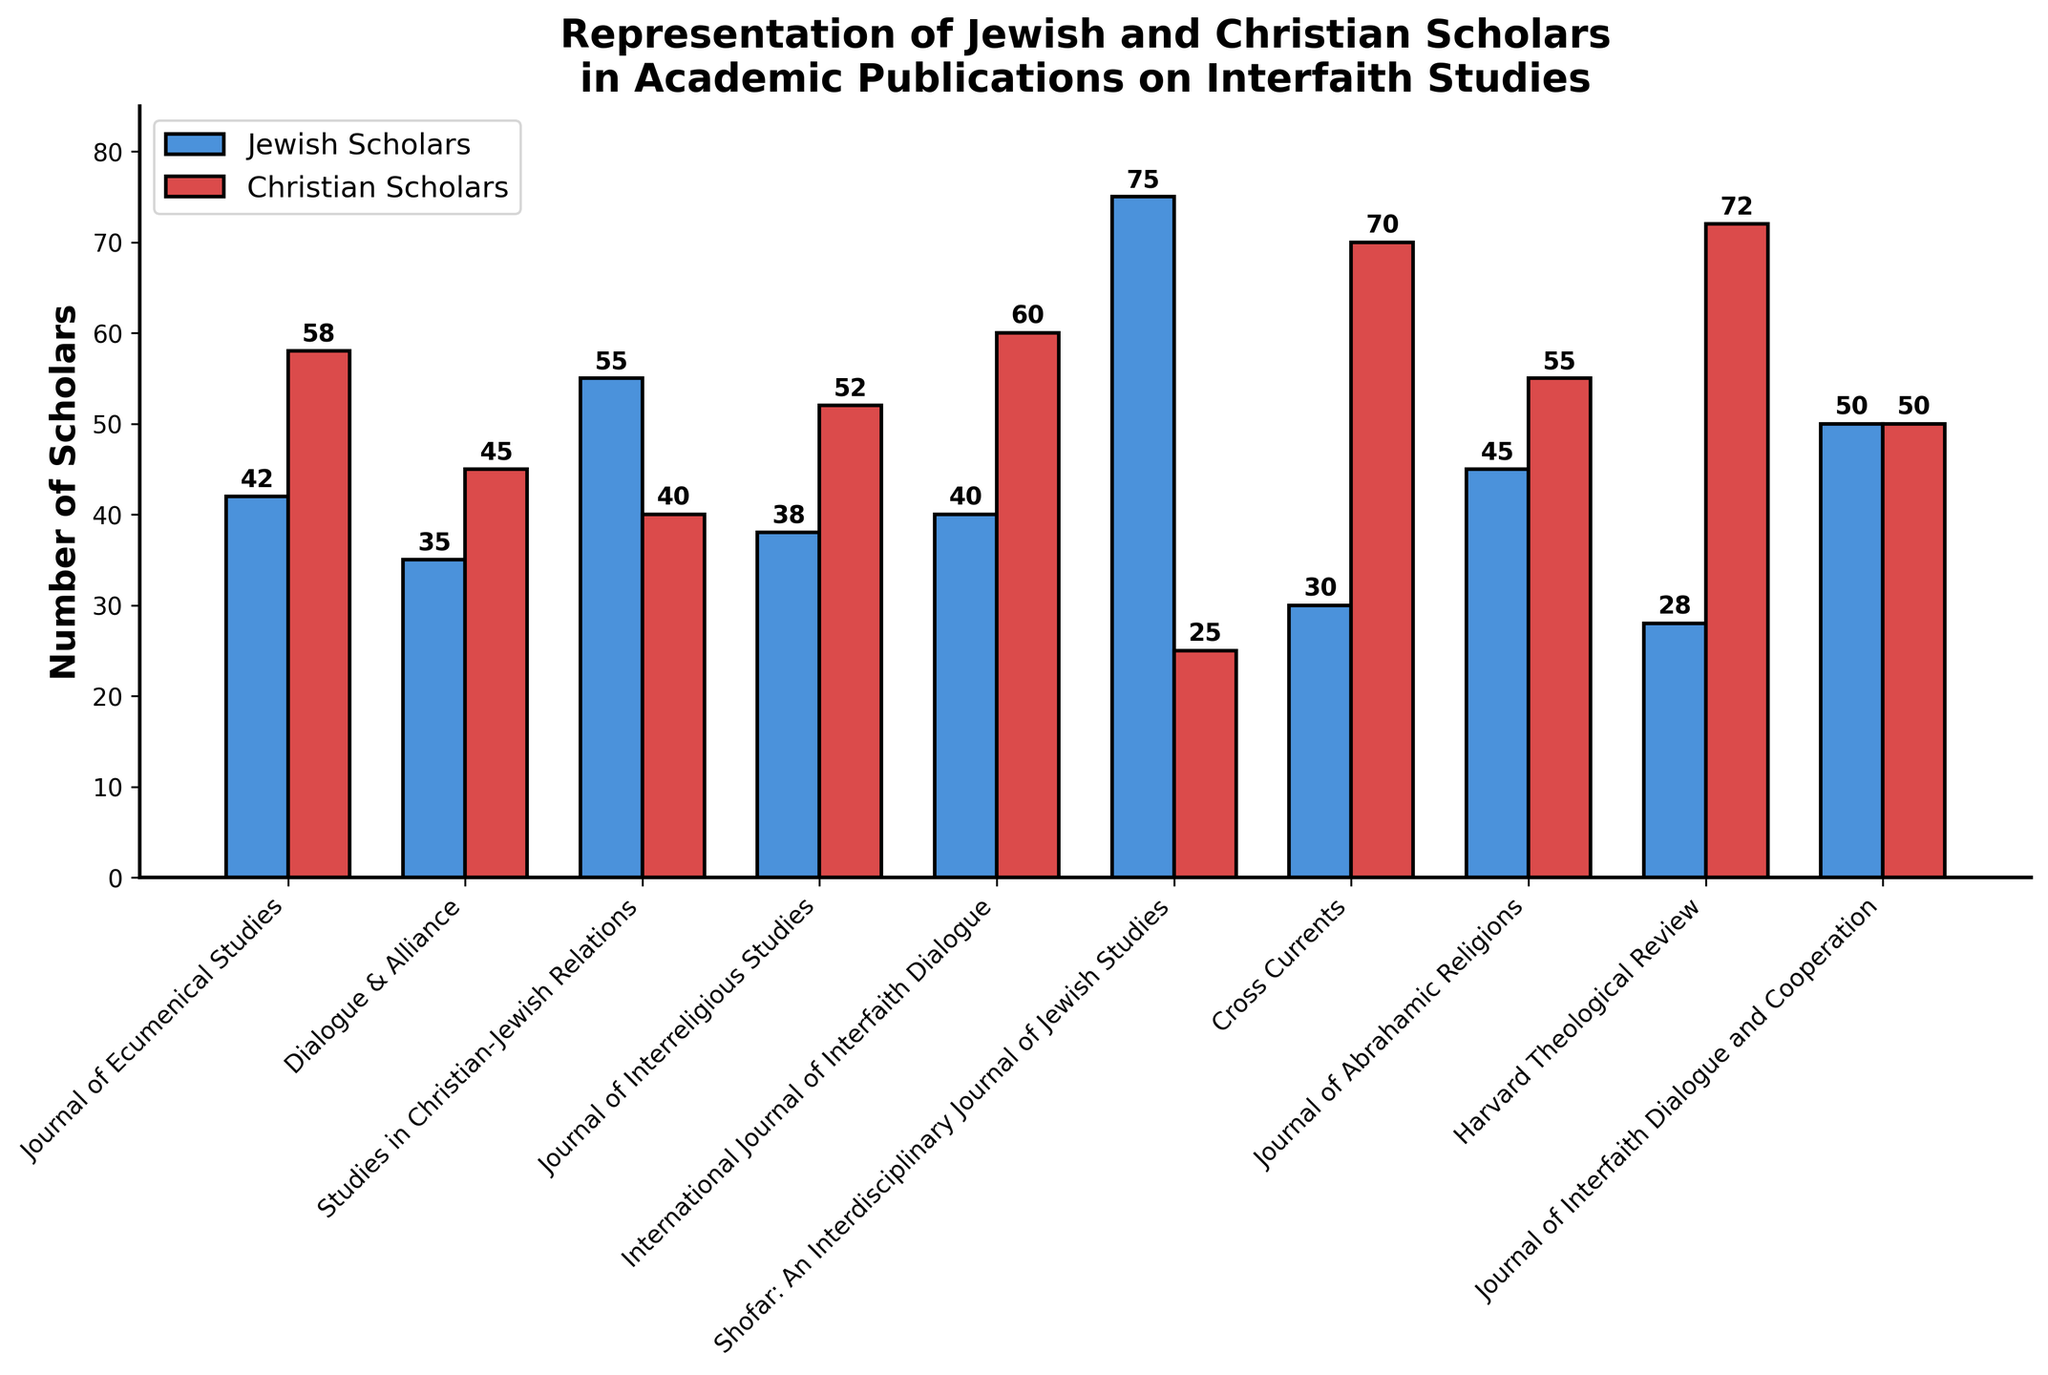What is the total number of scholars for the Journal of Ecumenical Studies? Add the number of Jewish and Christian scholars for the Journal of Ecumenical Studies (42 + 58).
Answer: 100 Which journal has the highest number of Jewish scholars? Compare the bar heights for Jewish Scholars across all journals. Shofar: An Interdisciplinary Journal of Jewish Studies has the highest bar with 75 Jewish scholars.
Answer: Shofar: An Interdisciplinary Journal of Jewish Studies What is the difference between the number of Jewish and Christian scholars in Shofar: An Interdisciplinary Journal of Jewish Studies? Subtract the number of Christian scholars from Jewish scholars for this journal (75 - 25).
Answer: 50 Which journal has an equal representation of Jewish and Christian scholars? Identify the journal where the bar heights for Jewish and Christian Scholars are equal. The Journal of Interfaith Dialogue and Cooperation has equal bars with 50 scholars each.
Answer: Journal of Interfaith Dialogue and Cooperation On average, how many Jewish scholars are published in Journal of Interreligious Studies and International Journal of Interfaith Dialogue? Add the number of Jewish scholars in both journals and divide by 2 ((38 + 40) / 2).
Answer: 39 Which journal has the greatest disparity between the number of Jewish and Christian scholars? Determine the differences between Jewish and Christian scholars for each journal. Harvard Theological Review has the greatest disparity (72 - 28 = 44).
Answer: Harvard Theological Review How many journals have more Christian scholars than Jewish scholars? Compare the heights of bars for Jewish and Christian scholars in each journal and count those where the Christian bar is higher. There are 5 such journals.
Answer: 5 Which journal has the least number of Christian scholars? Compare the bar heights for Christian Scholars across all journals. Shofar: An Interdisciplinary Journal of Jewish Studies has the smallest bar with 25 Christian scholars.
Answer: Shofar: An Interdisciplinary Journal of Jewish Studies What is the total number of Christian scholars across all journals? Add the number of Christian scholars for all journals (58 + 45 + 40 + 52 + 60 + 25 + 70 + 55 + 72 + 50).
Answer: 527 What is the relative representation of Jewish and Christian scholars in Dialogue & Alliance? Calculate the proportion of Jewish to Christian scholars for Dialogue & Alliance. The number of Jewish scholars is 35 and Christian scholars is 45. The ratio is 35/45 or approximately 0.78.
Answer: 0.78 